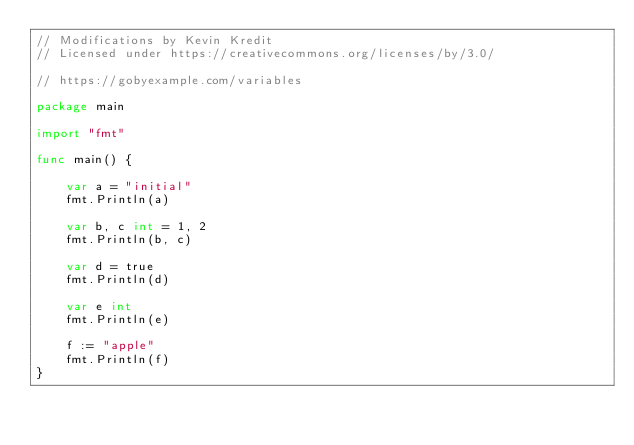Convert code to text. <code><loc_0><loc_0><loc_500><loc_500><_Go_>// Modifications by Kevin Kredit
// Licensed under https://creativecommons.org/licenses/by/3.0/

// https://gobyexample.com/variables

package main

import "fmt"

func main() {

    var a = "initial"
    fmt.Println(a)

    var b, c int = 1, 2
    fmt.Println(b, c)

    var d = true
    fmt.Println(d)

    var e int
    fmt.Println(e)

    f := "apple"
    fmt.Println(f)
}
</code> 